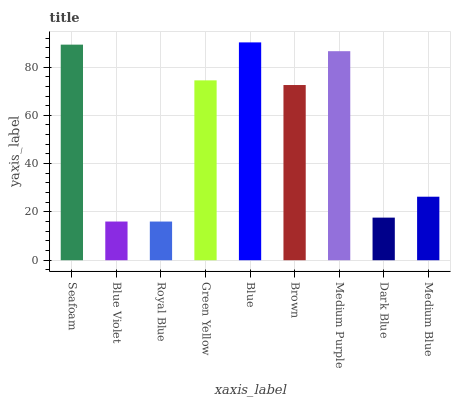Is Royal Blue the minimum?
Answer yes or no. Yes. Is Blue the maximum?
Answer yes or no. Yes. Is Blue Violet the minimum?
Answer yes or no. No. Is Blue Violet the maximum?
Answer yes or no. No. Is Seafoam greater than Blue Violet?
Answer yes or no. Yes. Is Blue Violet less than Seafoam?
Answer yes or no. Yes. Is Blue Violet greater than Seafoam?
Answer yes or no. No. Is Seafoam less than Blue Violet?
Answer yes or no. No. Is Brown the high median?
Answer yes or no. Yes. Is Brown the low median?
Answer yes or no. Yes. Is Medium Blue the high median?
Answer yes or no. No. Is Blue the low median?
Answer yes or no. No. 